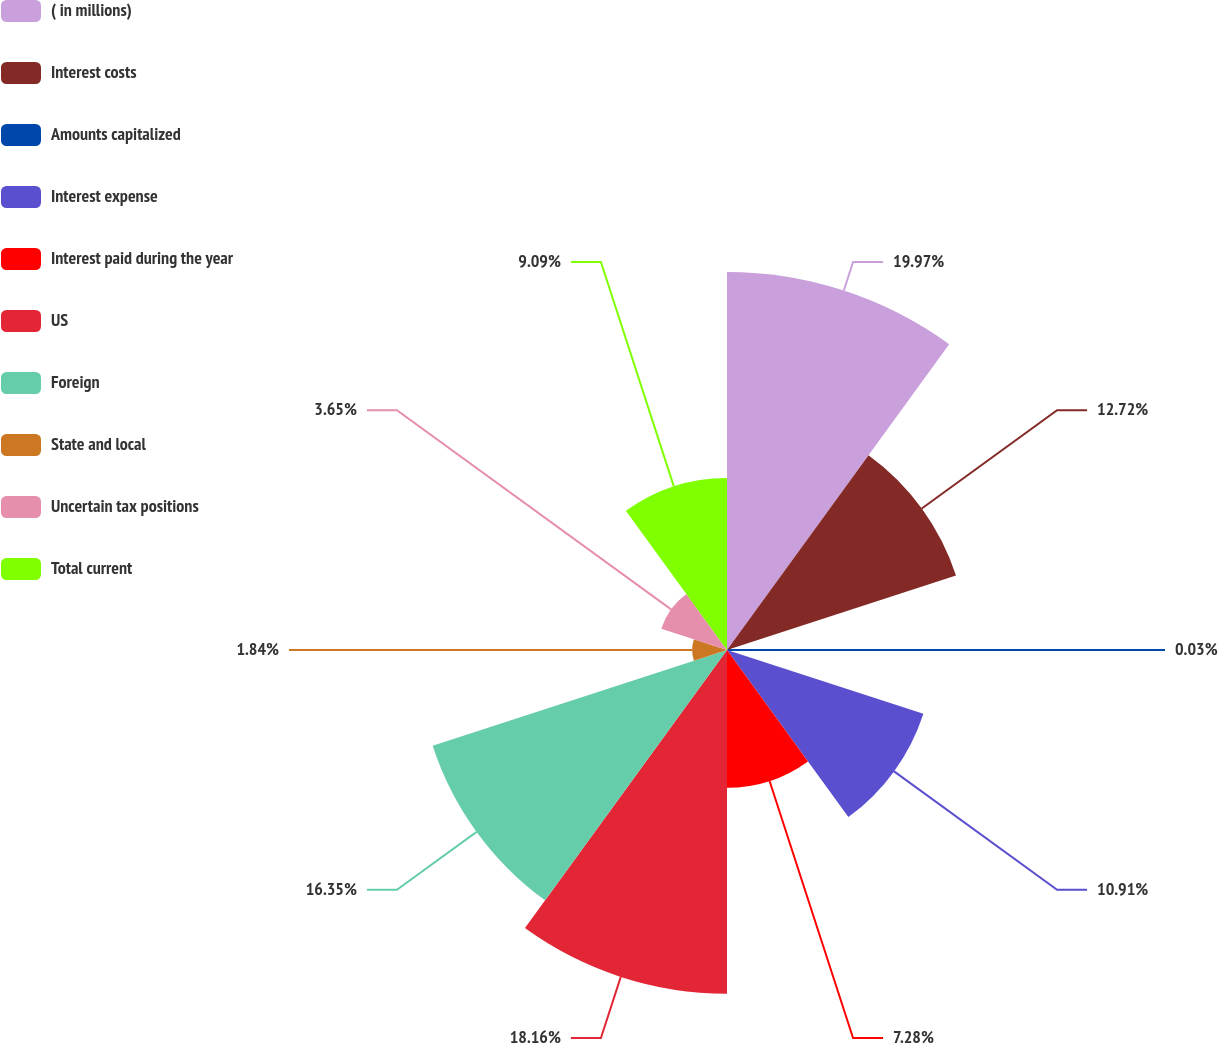<chart> <loc_0><loc_0><loc_500><loc_500><pie_chart><fcel>( in millions)<fcel>Interest costs<fcel>Amounts capitalized<fcel>Interest expense<fcel>Interest paid during the year<fcel>US<fcel>Foreign<fcel>State and local<fcel>Uncertain tax positions<fcel>Total current<nl><fcel>19.97%<fcel>12.72%<fcel>0.03%<fcel>10.91%<fcel>7.28%<fcel>18.16%<fcel>16.35%<fcel>1.84%<fcel>3.65%<fcel>9.09%<nl></chart> 